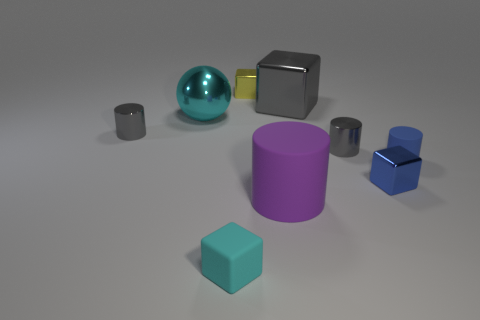Subtract 1 blocks. How many blocks are left? 3 Add 1 big cyan metallic objects. How many objects exist? 10 Subtract all blocks. How many objects are left? 5 Subtract all large blue rubber things. Subtract all large metallic objects. How many objects are left? 7 Add 4 small gray shiny objects. How many small gray shiny objects are left? 6 Add 9 brown cubes. How many brown cubes exist? 9 Subtract 0 yellow spheres. How many objects are left? 9 